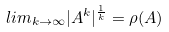<formula> <loc_0><loc_0><loc_500><loc_500>l i m _ { k \rightarrow \infty } | A ^ { k } | ^ { \frac { 1 } { k } } = \rho ( A )</formula> 